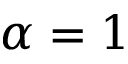<formula> <loc_0><loc_0><loc_500><loc_500>\alpha = 1</formula> 